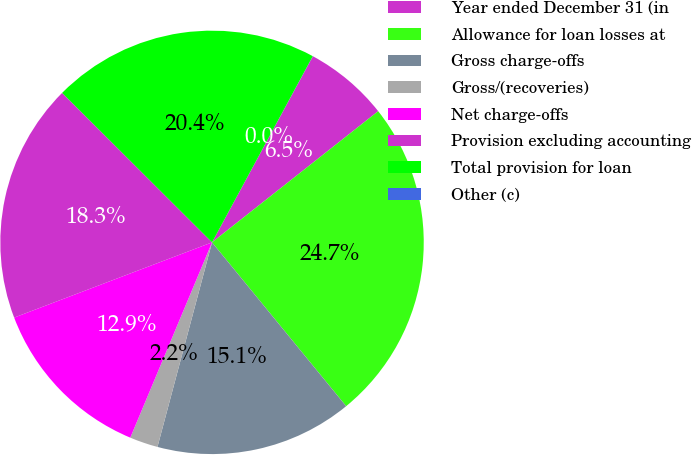<chart> <loc_0><loc_0><loc_500><loc_500><pie_chart><fcel>Year ended December 31 (in<fcel>Allowance for loan losses at<fcel>Gross charge-offs<fcel>Gross/(recoveries)<fcel>Net charge-offs<fcel>Provision excluding accounting<fcel>Total provision for loan<fcel>Other (c)<nl><fcel>6.46%<fcel>24.72%<fcel>15.07%<fcel>2.16%<fcel>12.91%<fcel>18.26%<fcel>20.42%<fcel>0.01%<nl></chart> 